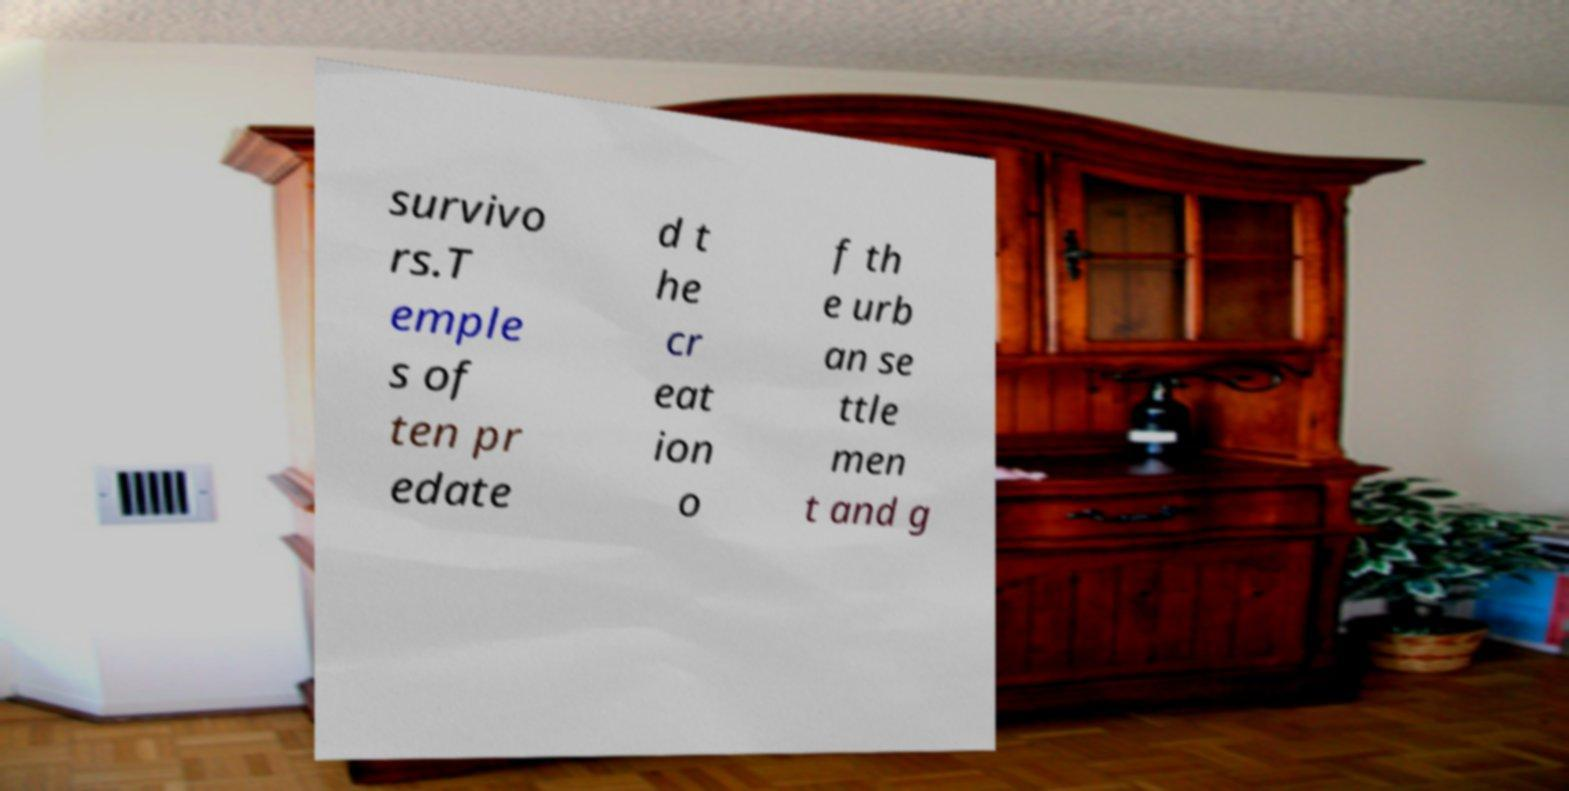There's text embedded in this image that I need extracted. Can you transcribe it verbatim? survivo rs.T emple s of ten pr edate d t he cr eat ion o f th e urb an se ttle men t and g 